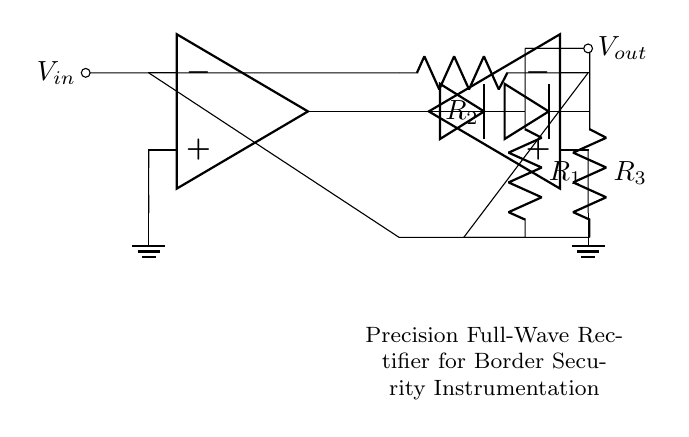What is the input voltage symbol in the circuit? The input voltage symbol is represented by \( V_{in} \), located on the left side of the op-amps where the incoming signal connects.
Answer: \( V_{in} \) What type of rectifier does this circuit implement? This is a precision full-wave rectifier circuit, indicated by the two operational amplifiers and the arrangement of diodes allowing bidirectional current flow.
Answer: Precision full-wave rectifier What are the values of the resistors labeled in the circuit? The resistors are labeled as \( R_1 \), \( R_2 \), and \( R_3 \). They do not have numerical values provided in the diagram, just their designations.
Answer: \( R_1, R_2, R_3 \) How many operational amplifiers are used in this circuit? There are two operational amplifiers (op-amps) in the circuit, shown side by side with distinct polarity configurations.
Answer: 2 What is the purpose of the diodes in this circuit? The diodes are used to allow current to pass in one direction while blocking it in the reverse direction, which is critical for rectification in this full-wave setup.
Answer: Rectification What is the output voltage symbol in the circuit? The output voltage symbol is represented by \( V_{out} \), located at the top right where the output signal is taken after processing.
Answer: \( V_{out} \) Why is a precision rectifier preferable for sensitive instrumentation? A precision rectifier reduces the error that voltage drop across diodes introduces in a standard rectifier configuration, ensuring accurate measurement, especially with low signal levels.
Answer: Accurate measurement 